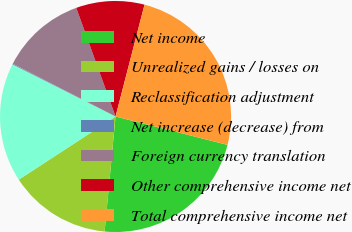Convert chart to OTSL. <chart><loc_0><loc_0><loc_500><loc_500><pie_chart><fcel>Net income<fcel>Unrealized gains / losses on<fcel>Reclassification adjustment<fcel>Net increase (decrease) from<fcel>Foreign currency translation<fcel>Other comprehensive income net<fcel>Total comprehensive income net<nl><fcel>22.56%<fcel>14.29%<fcel>16.66%<fcel>0.1%<fcel>11.92%<fcel>9.56%<fcel>24.92%<nl></chart> 